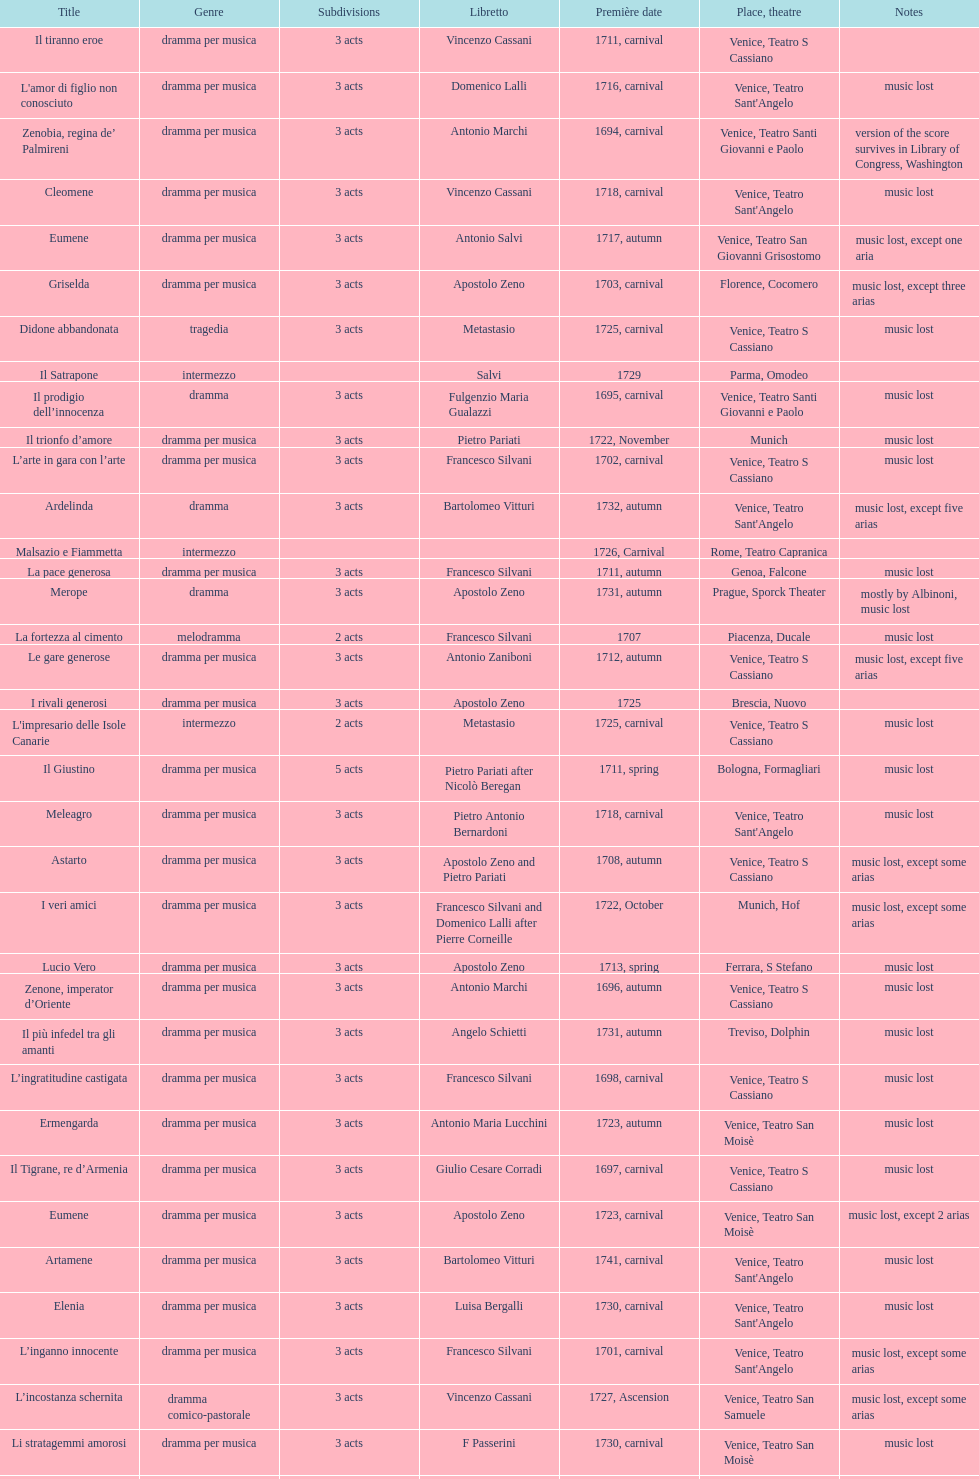Write the full table. {'header': ['Title', 'Genre', 'Sub\xaddivisions', 'Libretto', 'Première date', 'Place, theatre', 'Notes'], 'rows': [['Il tiranno eroe', 'dramma per musica', '3 acts', 'Vincenzo Cassani', '1711, carnival', 'Venice, Teatro S Cassiano', ''], ["L'amor di figlio non conosciuto", 'dramma per musica', '3 acts', 'Domenico Lalli', '1716, carnival', "Venice, Teatro Sant'Angelo", 'music lost'], ['Zenobia, regina de’ Palmireni', 'dramma per musica', '3 acts', 'Antonio Marchi', '1694, carnival', 'Venice, Teatro Santi Giovanni e Paolo', 'version of the score survives in Library of Congress, Washington'], ['Cleomene', 'dramma per musica', '3 acts', 'Vincenzo Cassani', '1718, carnival', "Venice, Teatro Sant'Angelo", 'music lost'], ['Eumene', 'dramma per musica', '3 acts', 'Antonio Salvi', '1717, autumn', 'Venice, Teatro San Giovanni Grisostomo', 'music lost, except one aria'], ['Griselda', 'dramma per musica', '3 acts', 'Apostolo Zeno', '1703, carnival', 'Florence, Cocomero', 'music lost, except three arias'], ['Didone abbandonata', 'tragedia', '3 acts', 'Metastasio', '1725, carnival', 'Venice, Teatro S Cassiano', 'music lost'], ['Il Satrapone', 'intermezzo', '', 'Salvi', '1729', 'Parma, Omodeo', ''], ['Il prodigio dell’innocenza', 'dramma', '3 acts', 'Fulgenzio Maria Gualazzi', '1695, carnival', 'Venice, Teatro Santi Giovanni e Paolo', 'music lost'], ['Il trionfo d’amore', 'dramma per musica', '3 acts', 'Pietro Pariati', '1722, November', 'Munich', 'music lost'], ['L’arte in gara con l’arte', 'dramma per musica', '3 acts', 'Francesco Silvani', '1702, carnival', 'Venice, Teatro S Cassiano', 'music lost'], ['Ardelinda', 'dramma', '3 acts', 'Bartolomeo Vitturi', '1732, autumn', "Venice, Teatro Sant'Angelo", 'music lost, except five arias'], ['Malsazio e Fiammetta', 'intermezzo', '', '', '1726, Carnival', 'Rome, Teatro Capranica', ''], ['La pace generosa', 'dramma per musica', '3 acts', 'Francesco Silvani', '1711, autumn', 'Genoa, Falcone', 'music lost'], ['Merope', 'dramma', '3 acts', 'Apostolo Zeno', '1731, autumn', 'Prague, Sporck Theater', 'mostly by Albinoni, music lost'], ['La fortezza al cimento', 'melodramma', '2 acts', 'Francesco Silvani', '1707', 'Piacenza, Ducale', 'music lost'], ['Le gare generose', 'dramma per musica', '3 acts', 'Antonio Zaniboni', '1712, autumn', 'Venice, Teatro S Cassiano', 'music lost, except five arias'], ['I rivali generosi', 'dramma per musica', '3 acts', 'Apostolo Zeno', '1725', 'Brescia, Nuovo', ''], ["L'impresario delle Isole Canarie", 'intermezzo', '2 acts', 'Metastasio', '1725, carnival', 'Venice, Teatro S Cassiano', 'music lost'], ['Il Giustino', 'dramma per musica', '5 acts', 'Pietro Pariati after Nicolò Beregan', '1711, spring', 'Bologna, Formagliari', 'music lost'], ['Meleagro', 'dramma per musica', '3 acts', 'Pietro Antonio Bernardoni', '1718, carnival', "Venice, Teatro Sant'Angelo", 'music lost'], ['Astarto', 'dramma per musica', '3 acts', 'Apostolo Zeno and Pietro Pariati', '1708, autumn', 'Venice, Teatro S Cassiano', 'music lost, except some arias'], ['I veri amici', 'dramma per musica', '3 acts', 'Francesco Silvani and Domenico Lalli after Pierre Corneille', '1722, October', 'Munich, Hof', 'music lost, except some arias'], ['Lucio Vero', 'dramma per musica', '3 acts', 'Apostolo Zeno', '1713, spring', 'Ferrara, S Stefano', 'music lost'], ['Zenone, imperator d’Oriente', 'dramma per musica', '3 acts', 'Antonio Marchi', '1696, autumn', 'Venice, Teatro S Cassiano', 'music lost'], ['Il più infedel tra gli amanti', 'dramma per musica', '3 acts', 'Angelo Schietti', '1731, autumn', 'Treviso, Dolphin', 'music lost'], ['L’ingratitudine castigata', 'dramma per musica', '3 acts', 'Francesco Silvani', '1698, carnival', 'Venice, Teatro S Cassiano', 'music lost'], ['Ermengarda', 'dramma per musica', '3 acts', 'Antonio Maria Lucchini', '1723, autumn', 'Venice, Teatro San Moisè', 'music lost'], ['Il Tigrane, re d’Armenia', 'dramma per musica', '3 acts', 'Giulio Cesare Corradi', '1697, carnival', 'Venice, Teatro S Cassiano', 'music lost'], ['Eumene', 'dramma per musica', '3 acts', 'Apostolo Zeno', '1723, carnival', 'Venice, Teatro San Moisè', 'music lost, except 2 arias'], ['Artamene', 'dramma per musica', '3 acts', 'Bartolomeo Vitturi', '1741, carnival', "Venice, Teatro Sant'Angelo", 'music lost'], ['Elenia', 'dramma per musica', '3 acts', 'Luisa Bergalli', '1730, carnival', "Venice, Teatro Sant'Angelo", 'music lost'], ['L’inganno innocente', 'dramma per musica', '3 acts', 'Francesco Silvani', '1701, carnival', "Venice, Teatro Sant'Angelo", 'music lost, except some arias'], ['L’incostanza schernita', 'dramma comico-pastorale', '3 acts', 'Vincenzo Cassani', '1727, Ascension', 'Venice, Teatro San Samuele', 'music lost, except some arias'], ['Li stratagemmi amorosi', 'dramma per musica', '3 acts', 'F Passerini', '1730, carnival', 'Venice, Teatro San Moisè', 'music lost'], ['Candalide', 'dramma per musica', '3 acts', 'Bartolomeo Vitturi', '1734, carnival', "Venice, Teatro Sant'Angelo", 'music lost'], ['Scipione nelle Spagne', 'dramma per musica', '3 acts', 'Apostolo Zeno', '1724, Ascension', 'Venice, Teatro San Samuele', 'music lost'], ['Aminta', 'dramma regio pastorale', '3 acts', 'Apostolo Zeno', '1703, autumn', 'Florence, Cocomero', 'music lost'], ['La Statira', 'dramma per musica', '3 acts', 'Apostolo Zeno and Pietro Pariati', '1726, Carnival', 'Rome, Teatro Capranica', ''], ['Il trionfo di Armida', 'dramma per musica', '3 acts', 'Girolamo Colatelli after Torquato Tasso', '1726, autumn', 'Venice, Teatro San Moisè', 'music lost'], ['Pimpinone', 'intermezzo', '3 intermezzos', 'Pietro Pariati', '1708, autumn', 'Venice, Teatro S Cassiano', ''], ['Engelberta', 'dramma per musica', '3 acts', 'Apostolo Zeno and Pietro Pariati', '1709, carnival', 'Venice, Teatro S Cassiano', '4th and 5th acts by Francesco Gasparini'], ['Primislao, primo re di Boemia', 'dramma per musica', '3 acts', 'Giulio Cesare Corradi', '1697, autumn', 'Venice, Teatro S Cassiano', 'music lost'], ['Il tradimento tradito', 'dramma per musica', '3 acts', 'Francesco Silvani', '1708, carnival', "Venice, Teatro Sant'Angelo", 'music lost'], ['Alcina delusa da Ruggero', 'dramma per musica', '3 acts', 'Antonio Marchi', '1725, autumn', 'Venice, Teatro S Cassiano', 'music lost'], ['Il più fedel tra i vassalli', 'dramma per musica', '3 acts', 'Francesco Silvani', '1705, autumn', 'Genoa, Falcone', 'music lost'], ['Radamisto', 'dramma per musica', '3 acts', 'Antonio Marchi', '1698, autumn', "Venice, Teatro Sant'Angelo", 'music lost'], ['Le due rivali in amore', 'dramma per musica', '3 acts', 'Aurelio Aureli', '1728, autumn', 'Venice, Teatro San Moisè', 'music lost'], ['Diomede punito da Alcide', 'dramma', '3 acts', 'Aurelio Aureli', '1700, autumn', "Venice, Teatro Sant'Angelo", 'music lost'], ['Laodice', 'dramma per musica', '3 acts', 'Angelo Schietti', '1724, autumn', 'Venice, Teatro San Moisè', 'music lost, except 2 arias'], ['Antigono, tutore di Filippo, re di Macedonia', 'tragedia', '5 acts', 'Giovanni Piazzon', '1724, carnival', 'Venice, Teatro San Moisè', '5th act by Giovanni Porta, music lost'], ['La fede tra gl’inganni', 'dramma per musica', '3 acts', 'Francesco Silvani', '1707, Carnival', "Venice, Teatro Sant'Angelo", 'music lost'], ['La prosperità di Elio Sejano', 'dramma per musica', '3 acts', 'Nicolò Minato', '1707, carnival', 'Genoa, Falcone', 'music lost'], ['Gli eccessi della gelosia', 'dramma per musica', '3 acts', 'Domenico Lalli', '1722, carnival', "Venice, Teatro Sant'Angelo", 'music lost, except some arias'], ['Ciro', 'dramma per musica', '3 acts', 'Pietro Pariati', '1710, carnival', 'Venice, Teatro S Cassiano', 'music lost']]} Which opera has the most acts, la fortezza al cimento or astarto? Astarto. 